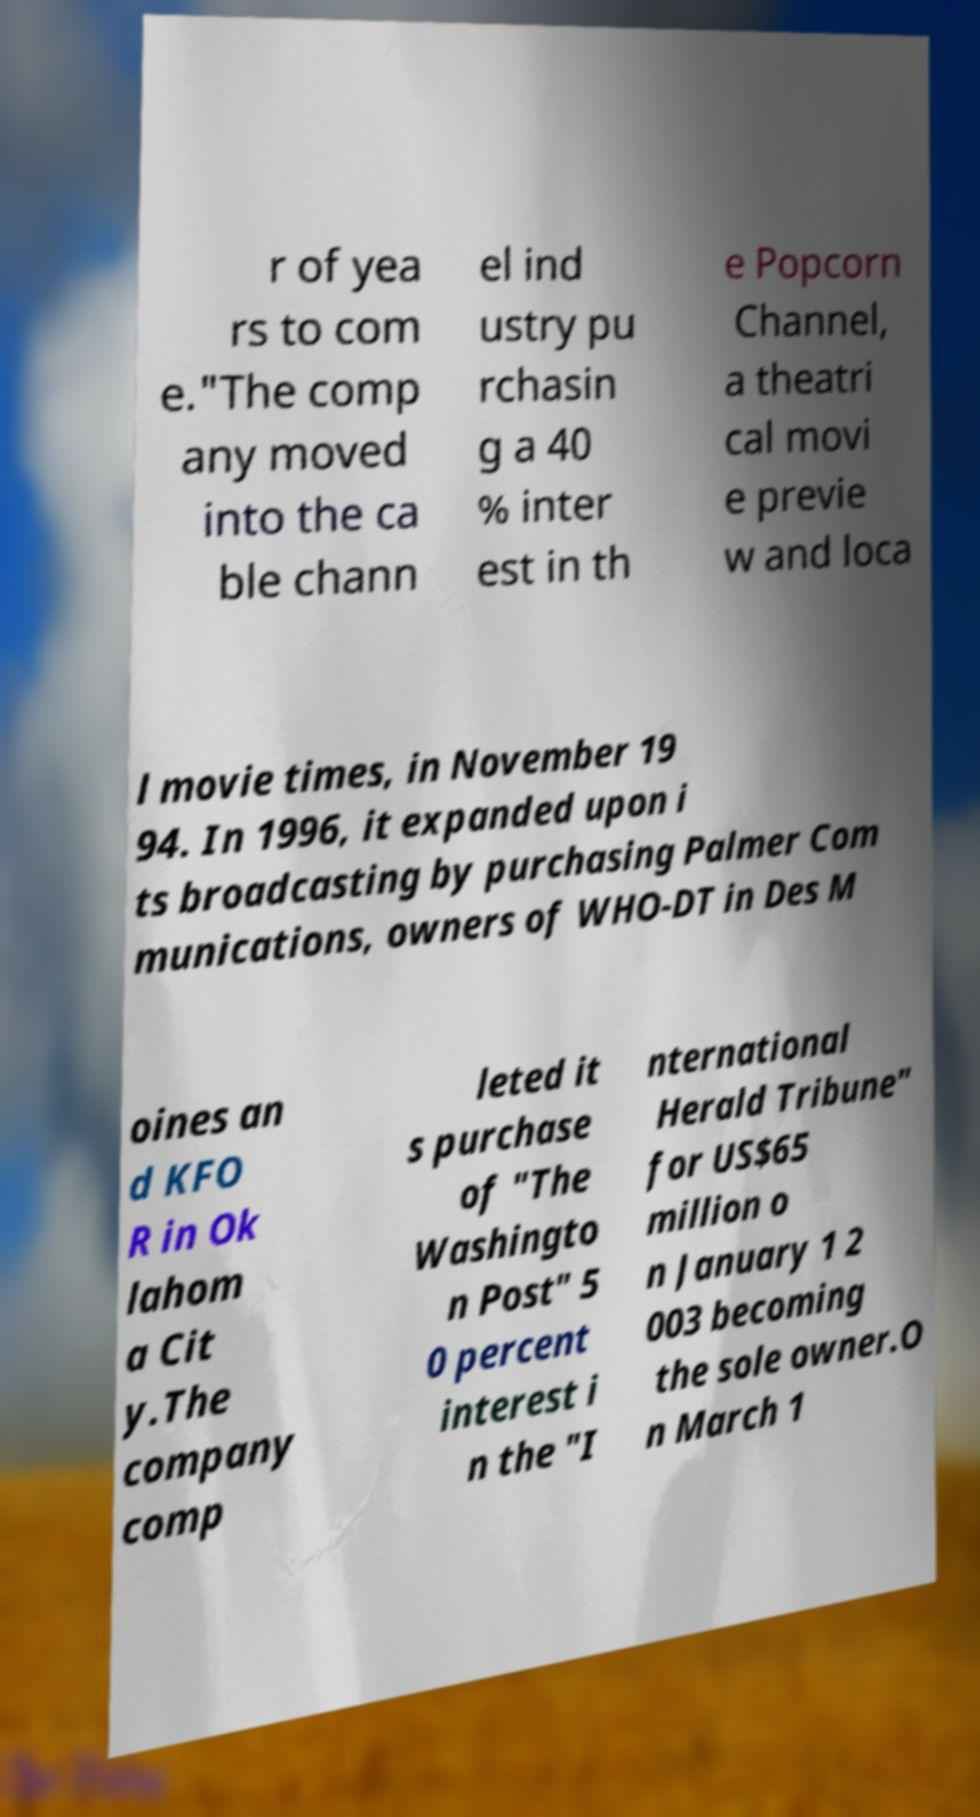There's text embedded in this image that I need extracted. Can you transcribe it verbatim? r of yea rs to com e."The comp any moved into the ca ble chann el ind ustry pu rchasin g a 40 % inter est in th e Popcorn Channel, a theatri cal movi e previe w and loca l movie times, in November 19 94. In 1996, it expanded upon i ts broadcasting by purchasing Palmer Com munications, owners of WHO-DT in Des M oines an d KFO R in Ok lahom a Cit y.The company comp leted it s purchase of "The Washingto n Post" 5 0 percent interest i n the "I nternational Herald Tribune" for US$65 million o n January 1 2 003 becoming the sole owner.O n March 1 